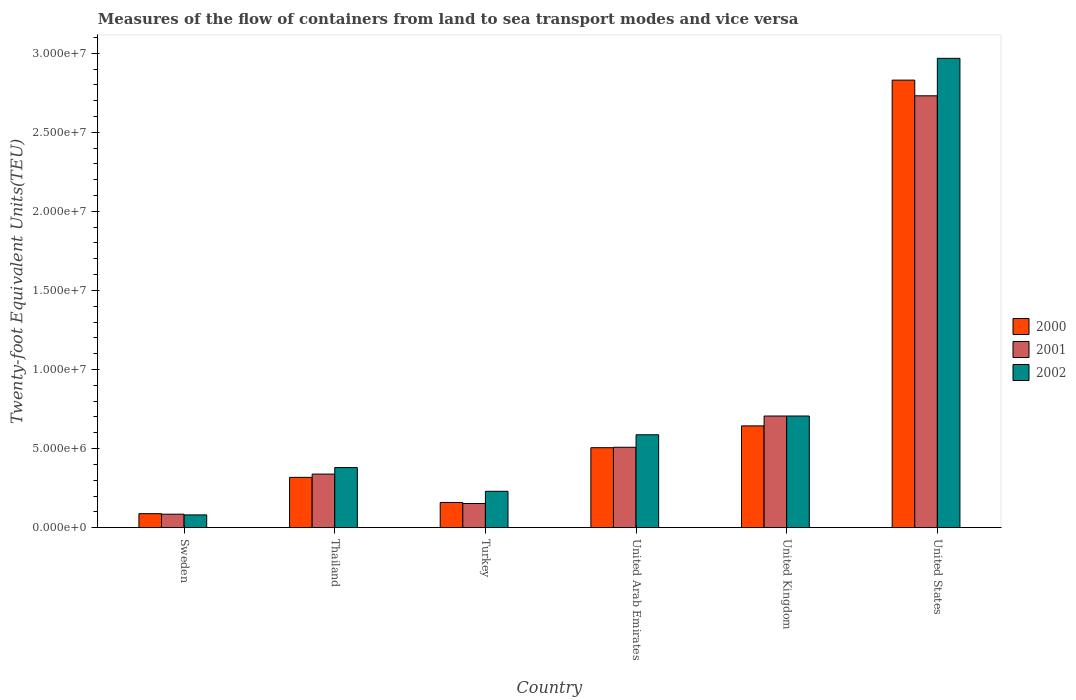How many groups of bars are there?
Make the answer very short. 6. Are the number of bars per tick equal to the number of legend labels?
Offer a very short reply. Yes. What is the label of the 2nd group of bars from the left?
Your answer should be compact. Thailand. In how many cases, is the number of bars for a given country not equal to the number of legend labels?
Provide a short and direct response. 0. What is the container port traffic in 2001 in United States?
Provide a short and direct response. 2.73e+07. Across all countries, what is the maximum container port traffic in 2001?
Give a very brief answer. 2.73e+07. Across all countries, what is the minimum container port traffic in 2001?
Keep it short and to the point. 8.51e+05. What is the total container port traffic in 2002 in the graph?
Ensure brevity in your answer.  4.95e+07. What is the difference between the container port traffic in 2001 in United Arab Emirates and that in United Kingdom?
Your response must be concise. -1.98e+06. What is the difference between the container port traffic in 2000 in Thailand and the container port traffic in 2002 in United Kingdom?
Your answer should be compact. -3.88e+06. What is the average container port traffic in 2000 per country?
Provide a short and direct response. 7.57e+06. What is the difference between the container port traffic of/in 2002 and container port traffic of/in 2000 in Sweden?
Provide a short and direct response. -7.85e+04. In how many countries, is the container port traffic in 2001 greater than 9000000 TEU?
Provide a short and direct response. 1. What is the ratio of the container port traffic in 2000 in Thailand to that in Turkey?
Offer a very short reply. 2. Is the container port traffic in 2001 in Sweden less than that in United Kingdom?
Your answer should be very brief. Yes. What is the difference between the highest and the second highest container port traffic in 2000?
Offer a terse response. 2.32e+07. What is the difference between the highest and the lowest container port traffic in 2001?
Your response must be concise. 2.65e+07. Is the sum of the container port traffic in 2002 in Thailand and United Kingdom greater than the maximum container port traffic in 2000 across all countries?
Offer a very short reply. No. What does the 1st bar from the right in United Kingdom represents?
Your response must be concise. 2002. Are all the bars in the graph horizontal?
Your answer should be compact. No. How many countries are there in the graph?
Give a very brief answer. 6. What is the difference between two consecutive major ticks on the Y-axis?
Your response must be concise. 5.00e+06. Are the values on the major ticks of Y-axis written in scientific E-notation?
Provide a short and direct response. Yes. Does the graph contain any zero values?
Your response must be concise. No. Does the graph contain grids?
Ensure brevity in your answer.  No. Where does the legend appear in the graph?
Provide a short and direct response. Center right. How many legend labels are there?
Offer a very short reply. 3. What is the title of the graph?
Your answer should be compact. Measures of the flow of containers from land to sea transport modes and vice versa. What is the label or title of the Y-axis?
Make the answer very short. Twenty-foot Equivalent Units(TEU). What is the Twenty-foot Equivalent Units(TEU) of 2000 in Sweden?
Provide a succinct answer. 8.84e+05. What is the Twenty-foot Equivalent Units(TEU) of 2001 in Sweden?
Offer a very short reply. 8.51e+05. What is the Twenty-foot Equivalent Units(TEU) of 2002 in Sweden?
Offer a terse response. 8.06e+05. What is the Twenty-foot Equivalent Units(TEU) of 2000 in Thailand?
Your answer should be compact. 3.18e+06. What is the Twenty-foot Equivalent Units(TEU) in 2001 in Thailand?
Make the answer very short. 3.39e+06. What is the Twenty-foot Equivalent Units(TEU) in 2002 in Thailand?
Offer a very short reply. 3.80e+06. What is the Twenty-foot Equivalent Units(TEU) in 2000 in Turkey?
Keep it short and to the point. 1.59e+06. What is the Twenty-foot Equivalent Units(TEU) of 2001 in Turkey?
Keep it short and to the point. 1.53e+06. What is the Twenty-foot Equivalent Units(TEU) in 2002 in Turkey?
Keep it short and to the point. 2.30e+06. What is the Twenty-foot Equivalent Units(TEU) in 2000 in United Arab Emirates?
Ensure brevity in your answer.  5.06e+06. What is the Twenty-foot Equivalent Units(TEU) of 2001 in United Arab Emirates?
Your response must be concise. 5.08e+06. What is the Twenty-foot Equivalent Units(TEU) in 2002 in United Arab Emirates?
Provide a succinct answer. 5.87e+06. What is the Twenty-foot Equivalent Units(TEU) in 2000 in United Kingdom?
Offer a very short reply. 6.43e+06. What is the Twenty-foot Equivalent Units(TEU) of 2001 in United Kingdom?
Provide a succinct answer. 7.06e+06. What is the Twenty-foot Equivalent Units(TEU) in 2002 in United Kingdom?
Provide a succinct answer. 7.06e+06. What is the Twenty-foot Equivalent Units(TEU) in 2000 in United States?
Give a very brief answer. 2.83e+07. What is the Twenty-foot Equivalent Units(TEU) of 2001 in United States?
Ensure brevity in your answer.  2.73e+07. What is the Twenty-foot Equivalent Units(TEU) in 2002 in United States?
Provide a succinct answer. 2.97e+07. Across all countries, what is the maximum Twenty-foot Equivalent Units(TEU) in 2000?
Ensure brevity in your answer.  2.83e+07. Across all countries, what is the maximum Twenty-foot Equivalent Units(TEU) of 2001?
Offer a very short reply. 2.73e+07. Across all countries, what is the maximum Twenty-foot Equivalent Units(TEU) of 2002?
Offer a very short reply. 2.97e+07. Across all countries, what is the minimum Twenty-foot Equivalent Units(TEU) of 2000?
Your answer should be very brief. 8.84e+05. Across all countries, what is the minimum Twenty-foot Equivalent Units(TEU) in 2001?
Your response must be concise. 8.51e+05. Across all countries, what is the minimum Twenty-foot Equivalent Units(TEU) of 2002?
Provide a succinct answer. 8.06e+05. What is the total Twenty-foot Equivalent Units(TEU) in 2000 in the graph?
Make the answer very short. 4.54e+07. What is the total Twenty-foot Equivalent Units(TEU) of 2001 in the graph?
Your answer should be very brief. 4.52e+07. What is the total Twenty-foot Equivalent Units(TEU) of 2002 in the graph?
Offer a very short reply. 4.95e+07. What is the difference between the Twenty-foot Equivalent Units(TEU) of 2000 in Sweden and that in Thailand?
Ensure brevity in your answer.  -2.29e+06. What is the difference between the Twenty-foot Equivalent Units(TEU) of 2001 in Sweden and that in Thailand?
Give a very brief answer. -2.54e+06. What is the difference between the Twenty-foot Equivalent Units(TEU) in 2002 in Sweden and that in Thailand?
Provide a short and direct response. -2.99e+06. What is the difference between the Twenty-foot Equivalent Units(TEU) of 2000 in Sweden and that in Turkey?
Offer a terse response. -7.08e+05. What is the difference between the Twenty-foot Equivalent Units(TEU) of 2001 in Sweden and that in Turkey?
Give a very brief answer. -6.75e+05. What is the difference between the Twenty-foot Equivalent Units(TEU) in 2002 in Sweden and that in Turkey?
Give a very brief answer. -1.49e+06. What is the difference between the Twenty-foot Equivalent Units(TEU) in 2000 in Sweden and that in United Arab Emirates?
Your answer should be very brief. -4.17e+06. What is the difference between the Twenty-foot Equivalent Units(TEU) of 2001 in Sweden and that in United Arab Emirates?
Give a very brief answer. -4.23e+06. What is the difference between the Twenty-foot Equivalent Units(TEU) in 2002 in Sweden and that in United Arab Emirates?
Keep it short and to the point. -5.07e+06. What is the difference between the Twenty-foot Equivalent Units(TEU) of 2000 in Sweden and that in United Kingdom?
Your answer should be compact. -5.55e+06. What is the difference between the Twenty-foot Equivalent Units(TEU) in 2001 in Sweden and that in United Kingdom?
Your answer should be very brief. -6.21e+06. What is the difference between the Twenty-foot Equivalent Units(TEU) of 2002 in Sweden and that in United Kingdom?
Keep it short and to the point. -6.25e+06. What is the difference between the Twenty-foot Equivalent Units(TEU) of 2000 in Sweden and that in United States?
Keep it short and to the point. -2.74e+07. What is the difference between the Twenty-foot Equivalent Units(TEU) of 2001 in Sweden and that in United States?
Make the answer very short. -2.65e+07. What is the difference between the Twenty-foot Equivalent Units(TEU) in 2002 in Sweden and that in United States?
Offer a very short reply. -2.89e+07. What is the difference between the Twenty-foot Equivalent Units(TEU) in 2000 in Thailand and that in Turkey?
Offer a very short reply. 1.59e+06. What is the difference between the Twenty-foot Equivalent Units(TEU) in 2001 in Thailand and that in Turkey?
Your answer should be compact. 1.86e+06. What is the difference between the Twenty-foot Equivalent Units(TEU) in 2002 in Thailand and that in Turkey?
Your answer should be compact. 1.50e+06. What is the difference between the Twenty-foot Equivalent Units(TEU) in 2000 in Thailand and that in United Arab Emirates?
Provide a succinct answer. -1.88e+06. What is the difference between the Twenty-foot Equivalent Units(TEU) of 2001 in Thailand and that in United Arab Emirates?
Keep it short and to the point. -1.69e+06. What is the difference between the Twenty-foot Equivalent Units(TEU) of 2002 in Thailand and that in United Arab Emirates?
Your response must be concise. -2.07e+06. What is the difference between the Twenty-foot Equivalent Units(TEU) in 2000 in Thailand and that in United Kingdom?
Provide a short and direct response. -3.26e+06. What is the difference between the Twenty-foot Equivalent Units(TEU) of 2001 in Thailand and that in United Kingdom?
Provide a short and direct response. -3.67e+06. What is the difference between the Twenty-foot Equivalent Units(TEU) in 2002 in Thailand and that in United Kingdom?
Give a very brief answer. -3.26e+06. What is the difference between the Twenty-foot Equivalent Units(TEU) in 2000 in Thailand and that in United States?
Give a very brief answer. -2.51e+07. What is the difference between the Twenty-foot Equivalent Units(TEU) in 2001 in Thailand and that in United States?
Offer a terse response. -2.39e+07. What is the difference between the Twenty-foot Equivalent Units(TEU) in 2002 in Thailand and that in United States?
Provide a succinct answer. -2.59e+07. What is the difference between the Twenty-foot Equivalent Units(TEU) in 2000 in Turkey and that in United Arab Emirates?
Offer a terse response. -3.46e+06. What is the difference between the Twenty-foot Equivalent Units(TEU) in 2001 in Turkey and that in United Arab Emirates?
Provide a short and direct response. -3.56e+06. What is the difference between the Twenty-foot Equivalent Units(TEU) of 2002 in Turkey and that in United Arab Emirates?
Make the answer very short. -3.57e+06. What is the difference between the Twenty-foot Equivalent Units(TEU) in 2000 in Turkey and that in United Kingdom?
Give a very brief answer. -4.84e+06. What is the difference between the Twenty-foot Equivalent Units(TEU) of 2001 in Turkey and that in United Kingdom?
Your response must be concise. -5.53e+06. What is the difference between the Twenty-foot Equivalent Units(TEU) in 2002 in Turkey and that in United Kingdom?
Make the answer very short. -4.76e+06. What is the difference between the Twenty-foot Equivalent Units(TEU) of 2000 in Turkey and that in United States?
Give a very brief answer. -2.67e+07. What is the difference between the Twenty-foot Equivalent Units(TEU) of 2001 in Turkey and that in United States?
Your answer should be compact. -2.58e+07. What is the difference between the Twenty-foot Equivalent Units(TEU) of 2002 in Turkey and that in United States?
Make the answer very short. -2.74e+07. What is the difference between the Twenty-foot Equivalent Units(TEU) of 2000 in United Arab Emirates and that in United Kingdom?
Your response must be concise. -1.38e+06. What is the difference between the Twenty-foot Equivalent Units(TEU) in 2001 in United Arab Emirates and that in United Kingdom?
Give a very brief answer. -1.98e+06. What is the difference between the Twenty-foot Equivalent Units(TEU) in 2002 in United Arab Emirates and that in United Kingdom?
Offer a very short reply. -1.19e+06. What is the difference between the Twenty-foot Equivalent Units(TEU) of 2000 in United Arab Emirates and that in United States?
Ensure brevity in your answer.  -2.32e+07. What is the difference between the Twenty-foot Equivalent Units(TEU) in 2001 in United Arab Emirates and that in United States?
Provide a succinct answer. -2.22e+07. What is the difference between the Twenty-foot Equivalent Units(TEU) in 2002 in United Arab Emirates and that in United States?
Keep it short and to the point. -2.38e+07. What is the difference between the Twenty-foot Equivalent Units(TEU) in 2000 in United Kingdom and that in United States?
Keep it short and to the point. -2.19e+07. What is the difference between the Twenty-foot Equivalent Units(TEU) of 2001 in United Kingdom and that in United States?
Offer a very short reply. -2.02e+07. What is the difference between the Twenty-foot Equivalent Units(TEU) in 2002 in United Kingdom and that in United States?
Provide a short and direct response. -2.26e+07. What is the difference between the Twenty-foot Equivalent Units(TEU) in 2000 in Sweden and the Twenty-foot Equivalent Units(TEU) in 2001 in Thailand?
Offer a very short reply. -2.50e+06. What is the difference between the Twenty-foot Equivalent Units(TEU) of 2000 in Sweden and the Twenty-foot Equivalent Units(TEU) of 2002 in Thailand?
Provide a succinct answer. -2.91e+06. What is the difference between the Twenty-foot Equivalent Units(TEU) of 2001 in Sweden and the Twenty-foot Equivalent Units(TEU) of 2002 in Thailand?
Ensure brevity in your answer.  -2.95e+06. What is the difference between the Twenty-foot Equivalent Units(TEU) in 2000 in Sweden and the Twenty-foot Equivalent Units(TEU) in 2001 in Turkey?
Provide a succinct answer. -6.42e+05. What is the difference between the Twenty-foot Equivalent Units(TEU) of 2000 in Sweden and the Twenty-foot Equivalent Units(TEU) of 2002 in Turkey?
Give a very brief answer. -1.41e+06. What is the difference between the Twenty-foot Equivalent Units(TEU) in 2001 in Sweden and the Twenty-foot Equivalent Units(TEU) in 2002 in Turkey?
Provide a short and direct response. -1.45e+06. What is the difference between the Twenty-foot Equivalent Units(TEU) in 2000 in Sweden and the Twenty-foot Equivalent Units(TEU) in 2001 in United Arab Emirates?
Keep it short and to the point. -4.20e+06. What is the difference between the Twenty-foot Equivalent Units(TEU) of 2000 in Sweden and the Twenty-foot Equivalent Units(TEU) of 2002 in United Arab Emirates?
Provide a succinct answer. -4.99e+06. What is the difference between the Twenty-foot Equivalent Units(TEU) in 2001 in Sweden and the Twenty-foot Equivalent Units(TEU) in 2002 in United Arab Emirates?
Your response must be concise. -5.02e+06. What is the difference between the Twenty-foot Equivalent Units(TEU) in 2000 in Sweden and the Twenty-foot Equivalent Units(TEU) in 2001 in United Kingdom?
Keep it short and to the point. -6.17e+06. What is the difference between the Twenty-foot Equivalent Units(TEU) in 2000 in Sweden and the Twenty-foot Equivalent Units(TEU) in 2002 in United Kingdom?
Provide a short and direct response. -6.18e+06. What is the difference between the Twenty-foot Equivalent Units(TEU) of 2001 in Sweden and the Twenty-foot Equivalent Units(TEU) of 2002 in United Kingdom?
Keep it short and to the point. -6.21e+06. What is the difference between the Twenty-foot Equivalent Units(TEU) of 2000 in Sweden and the Twenty-foot Equivalent Units(TEU) of 2001 in United States?
Make the answer very short. -2.64e+07. What is the difference between the Twenty-foot Equivalent Units(TEU) in 2000 in Sweden and the Twenty-foot Equivalent Units(TEU) in 2002 in United States?
Your response must be concise. -2.88e+07. What is the difference between the Twenty-foot Equivalent Units(TEU) of 2001 in Sweden and the Twenty-foot Equivalent Units(TEU) of 2002 in United States?
Make the answer very short. -2.88e+07. What is the difference between the Twenty-foot Equivalent Units(TEU) in 2000 in Thailand and the Twenty-foot Equivalent Units(TEU) in 2001 in Turkey?
Give a very brief answer. 1.65e+06. What is the difference between the Twenty-foot Equivalent Units(TEU) in 2000 in Thailand and the Twenty-foot Equivalent Units(TEU) in 2002 in Turkey?
Keep it short and to the point. 8.81e+05. What is the difference between the Twenty-foot Equivalent Units(TEU) of 2001 in Thailand and the Twenty-foot Equivalent Units(TEU) of 2002 in Turkey?
Offer a very short reply. 1.09e+06. What is the difference between the Twenty-foot Equivalent Units(TEU) in 2000 in Thailand and the Twenty-foot Equivalent Units(TEU) in 2001 in United Arab Emirates?
Ensure brevity in your answer.  -1.90e+06. What is the difference between the Twenty-foot Equivalent Units(TEU) of 2000 in Thailand and the Twenty-foot Equivalent Units(TEU) of 2002 in United Arab Emirates?
Provide a short and direct response. -2.69e+06. What is the difference between the Twenty-foot Equivalent Units(TEU) of 2001 in Thailand and the Twenty-foot Equivalent Units(TEU) of 2002 in United Arab Emirates?
Offer a terse response. -2.49e+06. What is the difference between the Twenty-foot Equivalent Units(TEU) in 2000 in Thailand and the Twenty-foot Equivalent Units(TEU) in 2001 in United Kingdom?
Your answer should be very brief. -3.88e+06. What is the difference between the Twenty-foot Equivalent Units(TEU) of 2000 in Thailand and the Twenty-foot Equivalent Units(TEU) of 2002 in United Kingdom?
Your response must be concise. -3.88e+06. What is the difference between the Twenty-foot Equivalent Units(TEU) of 2001 in Thailand and the Twenty-foot Equivalent Units(TEU) of 2002 in United Kingdom?
Provide a short and direct response. -3.67e+06. What is the difference between the Twenty-foot Equivalent Units(TEU) of 2000 in Thailand and the Twenty-foot Equivalent Units(TEU) of 2001 in United States?
Ensure brevity in your answer.  -2.41e+07. What is the difference between the Twenty-foot Equivalent Units(TEU) of 2000 in Thailand and the Twenty-foot Equivalent Units(TEU) of 2002 in United States?
Your response must be concise. -2.65e+07. What is the difference between the Twenty-foot Equivalent Units(TEU) of 2001 in Thailand and the Twenty-foot Equivalent Units(TEU) of 2002 in United States?
Provide a succinct answer. -2.63e+07. What is the difference between the Twenty-foot Equivalent Units(TEU) of 2000 in Turkey and the Twenty-foot Equivalent Units(TEU) of 2001 in United Arab Emirates?
Ensure brevity in your answer.  -3.49e+06. What is the difference between the Twenty-foot Equivalent Units(TEU) of 2000 in Turkey and the Twenty-foot Equivalent Units(TEU) of 2002 in United Arab Emirates?
Your answer should be compact. -4.28e+06. What is the difference between the Twenty-foot Equivalent Units(TEU) in 2001 in Turkey and the Twenty-foot Equivalent Units(TEU) in 2002 in United Arab Emirates?
Ensure brevity in your answer.  -4.35e+06. What is the difference between the Twenty-foot Equivalent Units(TEU) of 2000 in Turkey and the Twenty-foot Equivalent Units(TEU) of 2001 in United Kingdom?
Your answer should be very brief. -5.47e+06. What is the difference between the Twenty-foot Equivalent Units(TEU) of 2000 in Turkey and the Twenty-foot Equivalent Units(TEU) of 2002 in United Kingdom?
Ensure brevity in your answer.  -5.47e+06. What is the difference between the Twenty-foot Equivalent Units(TEU) of 2001 in Turkey and the Twenty-foot Equivalent Units(TEU) of 2002 in United Kingdom?
Your response must be concise. -5.53e+06. What is the difference between the Twenty-foot Equivalent Units(TEU) of 2000 in Turkey and the Twenty-foot Equivalent Units(TEU) of 2001 in United States?
Provide a succinct answer. -2.57e+07. What is the difference between the Twenty-foot Equivalent Units(TEU) of 2000 in Turkey and the Twenty-foot Equivalent Units(TEU) of 2002 in United States?
Your response must be concise. -2.81e+07. What is the difference between the Twenty-foot Equivalent Units(TEU) in 2001 in Turkey and the Twenty-foot Equivalent Units(TEU) in 2002 in United States?
Keep it short and to the point. -2.82e+07. What is the difference between the Twenty-foot Equivalent Units(TEU) of 2000 in United Arab Emirates and the Twenty-foot Equivalent Units(TEU) of 2001 in United Kingdom?
Give a very brief answer. -2.00e+06. What is the difference between the Twenty-foot Equivalent Units(TEU) of 2000 in United Arab Emirates and the Twenty-foot Equivalent Units(TEU) of 2002 in United Kingdom?
Make the answer very short. -2.00e+06. What is the difference between the Twenty-foot Equivalent Units(TEU) of 2001 in United Arab Emirates and the Twenty-foot Equivalent Units(TEU) of 2002 in United Kingdom?
Make the answer very short. -1.98e+06. What is the difference between the Twenty-foot Equivalent Units(TEU) in 2000 in United Arab Emirates and the Twenty-foot Equivalent Units(TEU) in 2001 in United States?
Provide a succinct answer. -2.23e+07. What is the difference between the Twenty-foot Equivalent Units(TEU) of 2000 in United Arab Emirates and the Twenty-foot Equivalent Units(TEU) of 2002 in United States?
Provide a short and direct response. -2.46e+07. What is the difference between the Twenty-foot Equivalent Units(TEU) of 2001 in United Arab Emirates and the Twenty-foot Equivalent Units(TEU) of 2002 in United States?
Your answer should be very brief. -2.46e+07. What is the difference between the Twenty-foot Equivalent Units(TEU) in 2000 in United Kingdom and the Twenty-foot Equivalent Units(TEU) in 2001 in United States?
Ensure brevity in your answer.  -2.09e+07. What is the difference between the Twenty-foot Equivalent Units(TEU) in 2000 in United Kingdom and the Twenty-foot Equivalent Units(TEU) in 2002 in United States?
Provide a succinct answer. -2.32e+07. What is the difference between the Twenty-foot Equivalent Units(TEU) in 2001 in United Kingdom and the Twenty-foot Equivalent Units(TEU) in 2002 in United States?
Make the answer very short. -2.26e+07. What is the average Twenty-foot Equivalent Units(TEU) of 2000 per country?
Offer a terse response. 7.57e+06. What is the average Twenty-foot Equivalent Units(TEU) of 2001 per country?
Offer a very short reply. 7.54e+06. What is the average Twenty-foot Equivalent Units(TEU) in 2002 per country?
Provide a succinct answer. 8.25e+06. What is the difference between the Twenty-foot Equivalent Units(TEU) of 2000 and Twenty-foot Equivalent Units(TEU) of 2001 in Sweden?
Provide a short and direct response. 3.29e+04. What is the difference between the Twenty-foot Equivalent Units(TEU) in 2000 and Twenty-foot Equivalent Units(TEU) in 2002 in Sweden?
Your answer should be compact. 7.85e+04. What is the difference between the Twenty-foot Equivalent Units(TEU) in 2001 and Twenty-foot Equivalent Units(TEU) in 2002 in Sweden?
Offer a very short reply. 4.56e+04. What is the difference between the Twenty-foot Equivalent Units(TEU) in 2000 and Twenty-foot Equivalent Units(TEU) in 2001 in Thailand?
Your answer should be very brief. -2.08e+05. What is the difference between the Twenty-foot Equivalent Units(TEU) in 2000 and Twenty-foot Equivalent Units(TEU) in 2002 in Thailand?
Your answer should be compact. -6.20e+05. What is the difference between the Twenty-foot Equivalent Units(TEU) in 2001 and Twenty-foot Equivalent Units(TEU) in 2002 in Thailand?
Your answer should be compact. -4.12e+05. What is the difference between the Twenty-foot Equivalent Units(TEU) of 2000 and Twenty-foot Equivalent Units(TEU) of 2001 in Turkey?
Ensure brevity in your answer.  6.52e+04. What is the difference between the Twenty-foot Equivalent Units(TEU) of 2000 and Twenty-foot Equivalent Units(TEU) of 2002 in Turkey?
Offer a terse response. -7.06e+05. What is the difference between the Twenty-foot Equivalent Units(TEU) in 2001 and Twenty-foot Equivalent Units(TEU) in 2002 in Turkey?
Your response must be concise. -7.71e+05. What is the difference between the Twenty-foot Equivalent Units(TEU) in 2000 and Twenty-foot Equivalent Units(TEU) in 2001 in United Arab Emirates?
Your answer should be very brief. -2.62e+04. What is the difference between the Twenty-foot Equivalent Units(TEU) of 2000 and Twenty-foot Equivalent Units(TEU) of 2002 in United Arab Emirates?
Your answer should be compact. -8.16e+05. What is the difference between the Twenty-foot Equivalent Units(TEU) of 2001 and Twenty-foot Equivalent Units(TEU) of 2002 in United Arab Emirates?
Your answer should be compact. -7.90e+05. What is the difference between the Twenty-foot Equivalent Units(TEU) of 2000 and Twenty-foot Equivalent Units(TEU) of 2001 in United Kingdom?
Offer a very short reply. -6.23e+05. What is the difference between the Twenty-foot Equivalent Units(TEU) in 2000 and Twenty-foot Equivalent Units(TEU) in 2002 in United Kingdom?
Make the answer very short. -6.25e+05. What is the difference between the Twenty-foot Equivalent Units(TEU) of 2001 and Twenty-foot Equivalent Units(TEU) of 2002 in United Kingdom?
Give a very brief answer. -1556. What is the difference between the Twenty-foot Equivalent Units(TEU) of 2000 and Twenty-foot Equivalent Units(TEU) of 2001 in United States?
Provide a succinct answer. 9.92e+05. What is the difference between the Twenty-foot Equivalent Units(TEU) of 2000 and Twenty-foot Equivalent Units(TEU) of 2002 in United States?
Offer a very short reply. -1.38e+06. What is the difference between the Twenty-foot Equivalent Units(TEU) in 2001 and Twenty-foot Equivalent Units(TEU) in 2002 in United States?
Offer a very short reply. -2.37e+06. What is the ratio of the Twenty-foot Equivalent Units(TEU) in 2000 in Sweden to that in Thailand?
Give a very brief answer. 0.28. What is the ratio of the Twenty-foot Equivalent Units(TEU) in 2001 in Sweden to that in Thailand?
Your answer should be very brief. 0.25. What is the ratio of the Twenty-foot Equivalent Units(TEU) in 2002 in Sweden to that in Thailand?
Keep it short and to the point. 0.21. What is the ratio of the Twenty-foot Equivalent Units(TEU) of 2000 in Sweden to that in Turkey?
Give a very brief answer. 0.56. What is the ratio of the Twenty-foot Equivalent Units(TEU) of 2001 in Sweden to that in Turkey?
Keep it short and to the point. 0.56. What is the ratio of the Twenty-foot Equivalent Units(TEU) in 2002 in Sweden to that in Turkey?
Offer a terse response. 0.35. What is the ratio of the Twenty-foot Equivalent Units(TEU) in 2000 in Sweden to that in United Arab Emirates?
Your answer should be very brief. 0.17. What is the ratio of the Twenty-foot Equivalent Units(TEU) of 2001 in Sweden to that in United Arab Emirates?
Ensure brevity in your answer.  0.17. What is the ratio of the Twenty-foot Equivalent Units(TEU) of 2002 in Sweden to that in United Arab Emirates?
Keep it short and to the point. 0.14. What is the ratio of the Twenty-foot Equivalent Units(TEU) in 2000 in Sweden to that in United Kingdom?
Provide a short and direct response. 0.14. What is the ratio of the Twenty-foot Equivalent Units(TEU) in 2001 in Sweden to that in United Kingdom?
Offer a very short reply. 0.12. What is the ratio of the Twenty-foot Equivalent Units(TEU) in 2002 in Sweden to that in United Kingdom?
Provide a succinct answer. 0.11. What is the ratio of the Twenty-foot Equivalent Units(TEU) of 2000 in Sweden to that in United States?
Provide a short and direct response. 0.03. What is the ratio of the Twenty-foot Equivalent Units(TEU) in 2001 in Sweden to that in United States?
Provide a short and direct response. 0.03. What is the ratio of the Twenty-foot Equivalent Units(TEU) in 2002 in Sweden to that in United States?
Keep it short and to the point. 0.03. What is the ratio of the Twenty-foot Equivalent Units(TEU) of 2000 in Thailand to that in Turkey?
Your answer should be very brief. 2. What is the ratio of the Twenty-foot Equivalent Units(TEU) of 2001 in Thailand to that in Turkey?
Provide a short and direct response. 2.22. What is the ratio of the Twenty-foot Equivalent Units(TEU) in 2002 in Thailand to that in Turkey?
Ensure brevity in your answer.  1.65. What is the ratio of the Twenty-foot Equivalent Units(TEU) in 2000 in Thailand to that in United Arab Emirates?
Give a very brief answer. 0.63. What is the ratio of the Twenty-foot Equivalent Units(TEU) in 2001 in Thailand to that in United Arab Emirates?
Provide a short and direct response. 0.67. What is the ratio of the Twenty-foot Equivalent Units(TEU) of 2002 in Thailand to that in United Arab Emirates?
Your response must be concise. 0.65. What is the ratio of the Twenty-foot Equivalent Units(TEU) of 2000 in Thailand to that in United Kingdom?
Keep it short and to the point. 0.49. What is the ratio of the Twenty-foot Equivalent Units(TEU) in 2001 in Thailand to that in United Kingdom?
Give a very brief answer. 0.48. What is the ratio of the Twenty-foot Equivalent Units(TEU) in 2002 in Thailand to that in United Kingdom?
Make the answer very short. 0.54. What is the ratio of the Twenty-foot Equivalent Units(TEU) of 2000 in Thailand to that in United States?
Provide a succinct answer. 0.11. What is the ratio of the Twenty-foot Equivalent Units(TEU) of 2001 in Thailand to that in United States?
Give a very brief answer. 0.12. What is the ratio of the Twenty-foot Equivalent Units(TEU) of 2002 in Thailand to that in United States?
Give a very brief answer. 0.13. What is the ratio of the Twenty-foot Equivalent Units(TEU) of 2000 in Turkey to that in United Arab Emirates?
Make the answer very short. 0.31. What is the ratio of the Twenty-foot Equivalent Units(TEU) in 2001 in Turkey to that in United Arab Emirates?
Give a very brief answer. 0.3. What is the ratio of the Twenty-foot Equivalent Units(TEU) of 2002 in Turkey to that in United Arab Emirates?
Offer a terse response. 0.39. What is the ratio of the Twenty-foot Equivalent Units(TEU) of 2000 in Turkey to that in United Kingdom?
Keep it short and to the point. 0.25. What is the ratio of the Twenty-foot Equivalent Units(TEU) of 2001 in Turkey to that in United Kingdom?
Keep it short and to the point. 0.22. What is the ratio of the Twenty-foot Equivalent Units(TEU) of 2002 in Turkey to that in United Kingdom?
Your answer should be very brief. 0.33. What is the ratio of the Twenty-foot Equivalent Units(TEU) in 2000 in Turkey to that in United States?
Offer a very short reply. 0.06. What is the ratio of the Twenty-foot Equivalent Units(TEU) of 2001 in Turkey to that in United States?
Offer a terse response. 0.06. What is the ratio of the Twenty-foot Equivalent Units(TEU) of 2002 in Turkey to that in United States?
Offer a terse response. 0.08. What is the ratio of the Twenty-foot Equivalent Units(TEU) in 2000 in United Arab Emirates to that in United Kingdom?
Offer a terse response. 0.79. What is the ratio of the Twenty-foot Equivalent Units(TEU) of 2001 in United Arab Emirates to that in United Kingdom?
Offer a very short reply. 0.72. What is the ratio of the Twenty-foot Equivalent Units(TEU) of 2002 in United Arab Emirates to that in United Kingdom?
Your response must be concise. 0.83. What is the ratio of the Twenty-foot Equivalent Units(TEU) in 2000 in United Arab Emirates to that in United States?
Provide a succinct answer. 0.18. What is the ratio of the Twenty-foot Equivalent Units(TEU) in 2001 in United Arab Emirates to that in United States?
Keep it short and to the point. 0.19. What is the ratio of the Twenty-foot Equivalent Units(TEU) in 2002 in United Arab Emirates to that in United States?
Provide a succinct answer. 0.2. What is the ratio of the Twenty-foot Equivalent Units(TEU) of 2000 in United Kingdom to that in United States?
Your response must be concise. 0.23. What is the ratio of the Twenty-foot Equivalent Units(TEU) of 2001 in United Kingdom to that in United States?
Your answer should be very brief. 0.26. What is the ratio of the Twenty-foot Equivalent Units(TEU) of 2002 in United Kingdom to that in United States?
Offer a terse response. 0.24. What is the difference between the highest and the second highest Twenty-foot Equivalent Units(TEU) of 2000?
Your response must be concise. 2.19e+07. What is the difference between the highest and the second highest Twenty-foot Equivalent Units(TEU) in 2001?
Give a very brief answer. 2.02e+07. What is the difference between the highest and the second highest Twenty-foot Equivalent Units(TEU) in 2002?
Give a very brief answer. 2.26e+07. What is the difference between the highest and the lowest Twenty-foot Equivalent Units(TEU) in 2000?
Ensure brevity in your answer.  2.74e+07. What is the difference between the highest and the lowest Twenty-foot Equivalent Units(TEU) in 2001?
Keep it short and to the point. 2.65e+07. What is the difference between the highest and the lowest Twenty-foot Equivalent Units(TEU) in 2002?
Provide a short and direct response. 2.89e+07. 